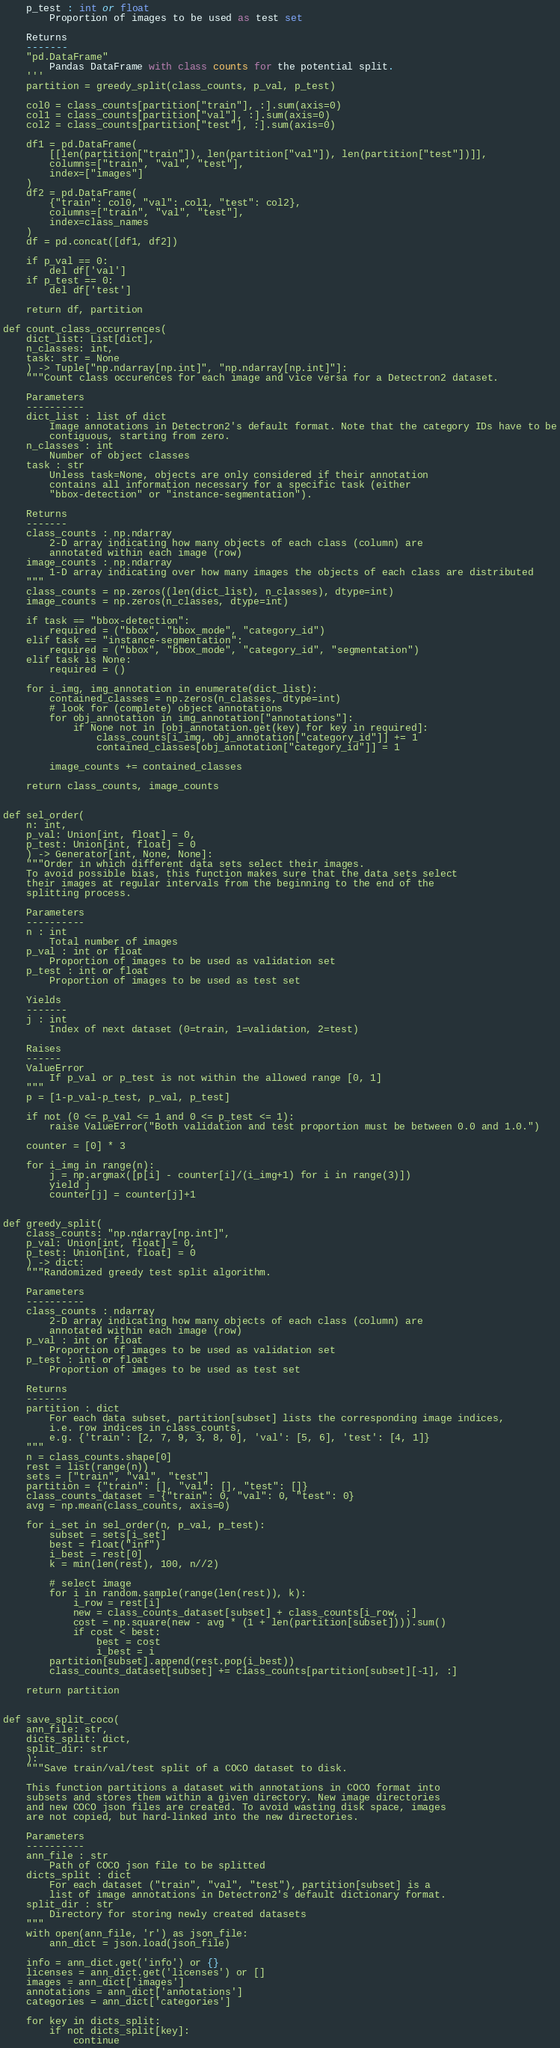Convert code to text. <code><loc_0><loc_0><loc_500><loc_500><_Python_>    p_test : int or float
        Proportion of images to be used as test set

    Returns
    -------
    "pd.DataFrame"
        Pandas DataFrame with class counts for the potential split.
    '''
    partition = greedy_split(class_counts, p_val, p_test)

    col0 = class_counts[partition["train"], :].sum(axis=0)
    col1 = class_counts[partition["val"], :].sum(axis=0)
    col2 = class_counts[partition["test"], :].sum(axis=0)

    df1 = pd.DataFrame(
        [[len(partition["train"]), len(partition["val"]), len(partition["test"])]],
        columns=["train", "val", "test"],
        index=["images"]
    )
    df2 = pd.DataFrame(
        {"train": col0, "val": col1, "test": col2},
        columns=["train", "val", "test"],
        index=class_names
    )
    df = pd.concat([df1, df2])

    if p_val == 0:
        del df['val']
    if p_test == 0:
        del df['test']

    return df, partition

def count_class_occurrences(
    dict_list: List[dict],
    n_classes: int,
    task: str = None
    ) -> Tuple["np.ndarray[np.int]", "np.ndarray[np.int]"]:
    """Count class occurences for each image and vice versa for a Detectron2 dataset.

    Parameters
    ----------
    dict_list : list of dict
        Image annotations in Detectron2's default format. Note that the category IDs have to be
        contiguous, starting from zero.
    n_classes : int
        Number of object classes
    task : str
        Unless task=None, objects are only considered if their annotation
        contains all information necessary for a specific task (either
        "bbox-detection" or "instance-segmentation").

    Returns
    -------
    class_counts : np.ndarray
        2-D array indicating how many objects of each class (column) are
        annotated within each image (row)
    image_counts : np.ndarray
        1-D array indicating over how many images the objects of each class are distributed
    """
    class_counts = np.zeros((len(dict_list), n_classes), dtype=int)
    image_counts = np.zeros(n_classes, dtype=int)

    if task == "bbox-detection":
        required = ("bbox", "bbox_mode", "category_id")
    elif task == "instance-segmentation":
        required = ("bbox", "bbox_mode", "category_id", "segmentation")
    elif task is None:
        required = ()

    for i_img, img_annotation in enumerate(dict_list):
        contained_classes = np.zeros(n_classes, dtype=int)
        # look for (complete) object annotations
        for obj_annotation in img_annotation["annotations"]:
            if None not in [obj_annotation.get(key) for key in required]:
                class_counts[i_img, obj_annotation["category_id"]] += 1
                contained_classes[obj_annotation["category_id"]] = 1

        image_counts += contained_classes

    return class_counts, image_counts


def sel_order(
    n: int,
    p_val: Union[int, float] = 0,
    p_test: Union[int, float] = 0
    ) -> Generator[int, None, None]:
    """Order in which different data sets select their images.
    To avoid possible bias, this function makes sure that the data sets select
    their images at regular intervals from the beginning to the end of the
    splitting process.

    Parameters
    ----------
    n : int
        Total number of images
    p_val : int or float
        Proportion of images to be used as validation set
    p_test : int or float
        Proportion of images to be used as test set

    Yields
    -------
    j : int
        Index of next dataset (0=train, 1=validation, 2=test)

    Raises
    ------
    ValueError
        If p_val or p_test is not within the allowed range [0, 1]
    """
    p = [1-p_val-p_test, p_val, p_test]

    if not (0 <= p_val <= 1 and 0 <= p_test <= 1):
        raise ValueError("Both validation and test proportion must be between 0.0 and 1.0.")

    counter = [0] * 3

    for i_img in range(n):
        j = np.argmax([p[i] - counter[i]/(i_img+1) for i in range(3)])
        yield j
        counter[j] = counter[j]+1


def greedy_split(
    class_counts: "np.ndarray[np.int]",
    p_val: Union[int, float] = 0,
    p_test: Union[int, float] = 0
    ) -> dict:
    """Randomized greedy test split algorithm.

    Parameters
    ----------
    class_counts : ndarray
        2-D array indicating how many objects of each class (column) are
        annotated within each image (row)
    p_val : int or float
        Proportion of images to be used as validation set
    p_test : int or float
        Proportion of images to be used as test set

    Returns
    -------
    partition : dict
        For each data subset, partition[subset] lists the corresponding image indices,
        i.e. row indices in class_counts,
        e.g. {'train': [2, 7, 9, 3, 8, 0], 'val': [5, 6], 'test': [4, 1]}
    """
    n = class_counts.shape[0]
    rest = list(range(n))
    sets = ["train", "val", "test"]
    partition = {"train": [], "val": [], "test": []}
    class_counts_dataset = {"train": 0, "val": 0, "test": 0}
    avg = np.mean(class_counts, axis=0)

    for i_set in sel_order(n, p_val, p_test):
        subset = sets[i_set]
        best = float("inf")
        i_best = rest[0]
        k = min(len(rest), 100, n//2)

        # select image
        for i in random.sample(range(len(rest)), k):
            i_row = rest[i]
            new = class_counts_dataset[subset] + class_counts[i_row, :]
            cost = np.square(new - avg * (1 + len(partition[subset]))).sum()
            if cost < best:
                best = cost
                i_best = i
        partition[subset].append(rest.pop(i_best))
        class_counts_dataset[subset] += class_counts[partition[subset][-1], :]

    return partition


def save_split_coco(
    ann_file: str,
    dicts_split: dict,
    split_dir: str
    ):
    """Save train/val/test split of a COCO dataset to disk.

    This function partitions a dataset with annotations in COCO format into
    subsets and stores them within a given directory. New image directories
    and new COCO json files are created. To avoid wasting disk space, images
    are not copied, but hard-linked into the new directories.

    Parameters
    ----------
    ann_file : str
        Path of COCO json file to be splitted
    dicts_split : dict
        For each dataset ("train", "val", "test"), partition[subset] is a
        list of image annotations in Detectron2's default dictionary format.
    split_dir : str
        Directory for storing newly created datasets
    """
    with open(ann_file, 'r') as json_file:
        ann_dict = json.load(json_file)

    info = ann_dict.get('info') or {}
    licenses = ann_dict.get('licenses') or []
    images = ann_dict['images']
    annotations = ann_dict['annotations']
    categories = ann_dict['categories']

    for key in dicts_split:
        if not dicts_split[key]:
            continue
</code> 